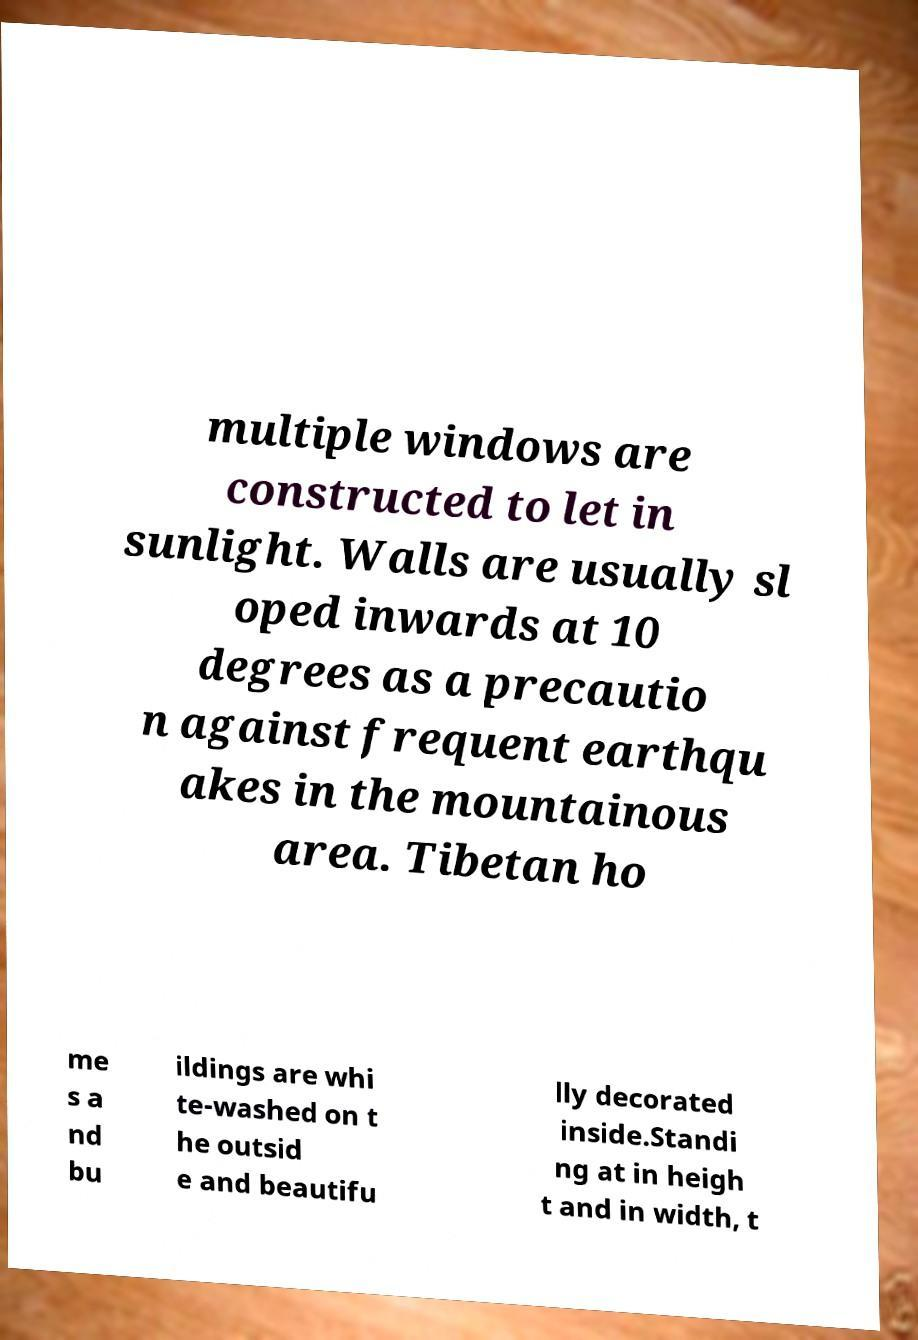Could you extract and type out the text from this image? multiple windows are constructed to let in sunlight. Walls are usually sl oped inwards at 10 degrees as a precautio n against frequent earthqu akes in the mountainous area. Tibetan ho me s a nd bu ildings are whi te-washed on t he outsid e and beautifu lly decorated inside.Standi ng at in heigh t and in width, t 